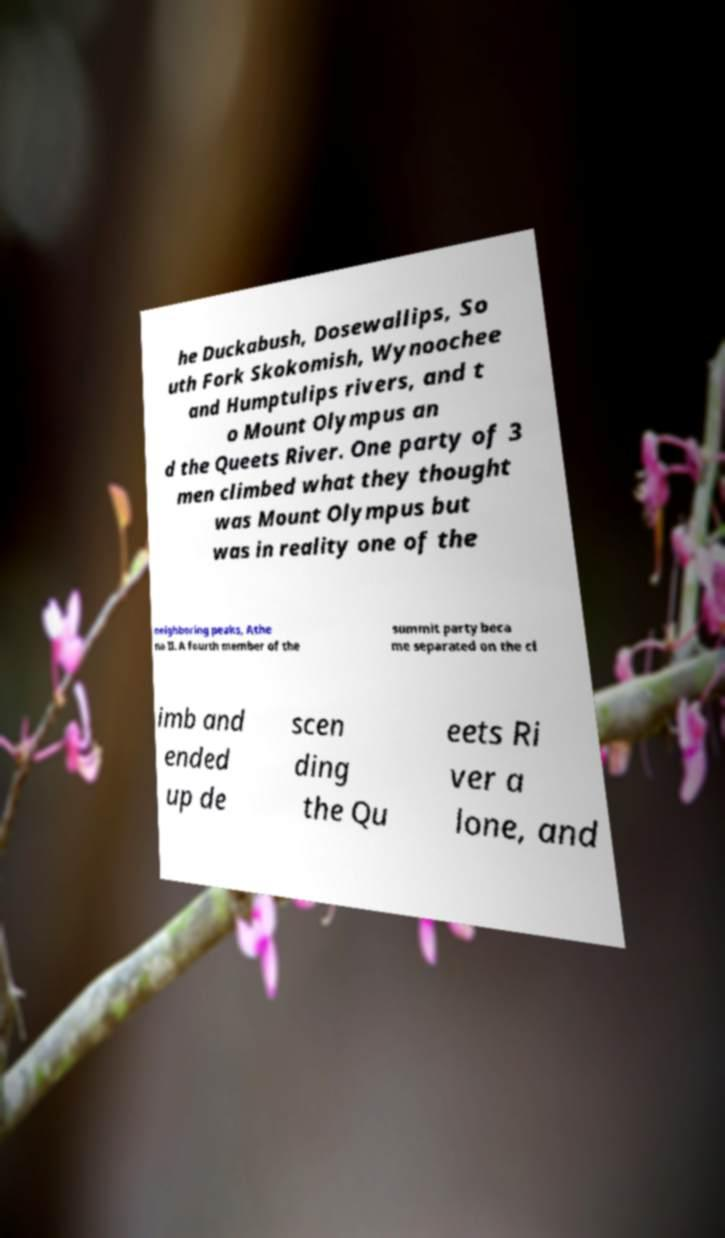Please read and relay the text visible in this image. What does it say? he Duckabush, Dosewallips, So uth Fork Skokomish, Wynoochee and Humptulips rivers, and t o Mount Olympus an d the Queets River. One party of 3 men climbed what they thought was Mount Olympus but was in reality one of the neighboring peaks, Athe na II. A fourth member of the summit party beca me separated on the cl imb and ended up de scen ding the Qu eets Ri ver a lone, and 